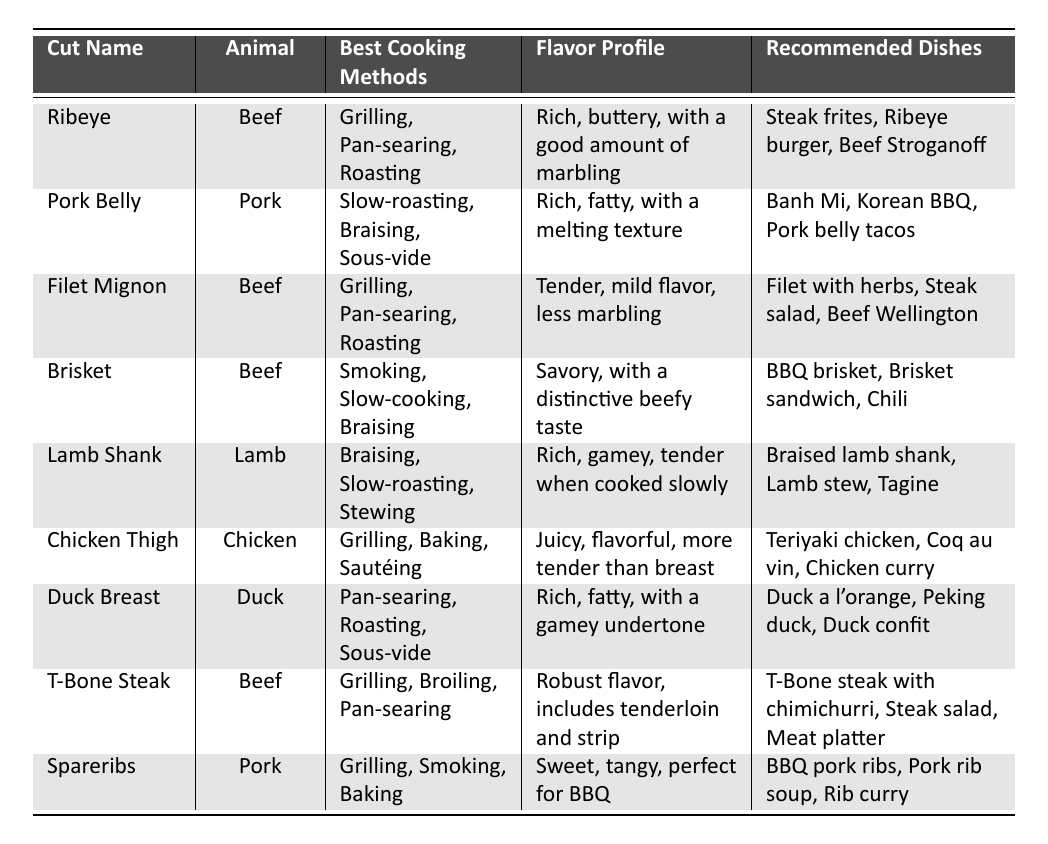What are the best cooking methods for Ribeye? The table lists the best cooking methods for Ribeye as Grilling, Pan-searing, and Roasting.
Answer: Grilling, Pan-searing, Roasting Which meat cut has a flavor profile described as rich, fatty, with a melting texture? According to the table, Pork Belly has the flavor profile of rich, fatty, with a melting texture.
Answer: Pork Belly How many recommended dishes are there for Duck Breast? The table shows that Duck Breast has three recommended dishes: Duck a l'orange, Peking duck, and Duck confit.
Answer: Three True or False: Brisket is best cooked using grilling. The table indicates that Brisket is best cooked using Smoking, Slow-cooking, and Braising, not grilling, so this statement is false.
Answer: False What is the difference in cooking methods between Chicken Thigh and Lamb Shank? Chicken Thigh is best cooked by Grilling, Baking, and Sautéing, while Lamb Shank is best cooked by Braising, Slow-roasting, and Stewing, showing different preferred methods for each cut.
Answer: Different cooking methods Which beef cut has the most recommended dishes? Both Ribeye and Filet Mignon have three recommended dishes, while other beef cuts mentioned have fewer, indicating they are tied for most recommended dishes.
Answer: Tied (Ribeye and Filet Mignon) What is the flavor profile of Spareribs? The flavor profile of Spareribs is described in the table as sweet, tangy, perfect for BBQ.
Answer: Sweet, tangy, perfect for BBQ List all the cooking methods for T-Bone Steak. The table shows that T-Bone Steak can be cooked using Grilling, Broiling, and Pan-searing.
Answer: Grilling, Broiling, Pan-searing How does the flavor profile of Duck Breast compare to that of Chicken Thigh? Duck Breast has a rich, fatty flavor with a gamey undertone, while Chicken Thigh is juicy and flavorful. This indicates Duck Breast is richer compared to the more straightforward flavor of Chicken Thigh.
Answer: Duck Breast is richer Which meat cut is the only one that is primarily associated with sous-vide cooking? The table shows that Pork Belly and Duck Breast both mention sous-vide, but Duck Breast is notably listed twice under different cooking methods; therefore, it distinctly highlights its use.
Answer: Duck Breast 